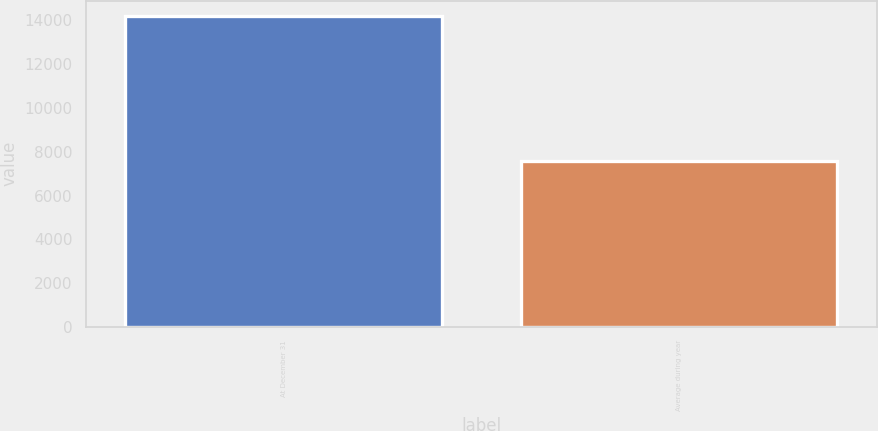Convert chart to OTSL. <chart><loc_0><loc_0><loc_500><loc_500><bar_chart><fcel>At December 31<fcel>Average during year<nl><fcel>14187<fcel>7595<nl></chart> 